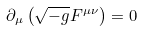Convert formula to latex. <formula><loc_0><loc_0><loc_500><loc_500>\partial _ { \mu } \left ( \sqrt { - g } F ^ { \mu \nu } \right ) = 0</formula> 